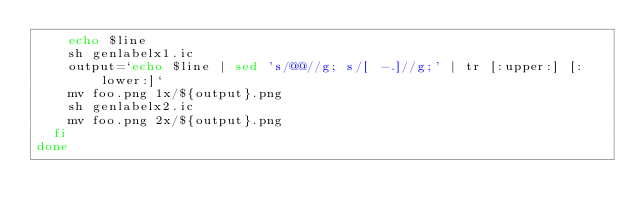<code> <loc_0><loc_0><loc_500><loc_500><_Bash_>    echo $line
    sh genlabelx1.ic
    output=`echo $line | sed 's/@@//g; s/[ -.]//g;' | tr [:upper:] [:lower:]`
    mv foo.png 1x/${output}.png
    sh genlabelx2.ic
    mv foo.png 2x/${output}.png
  fi
done
</code> 